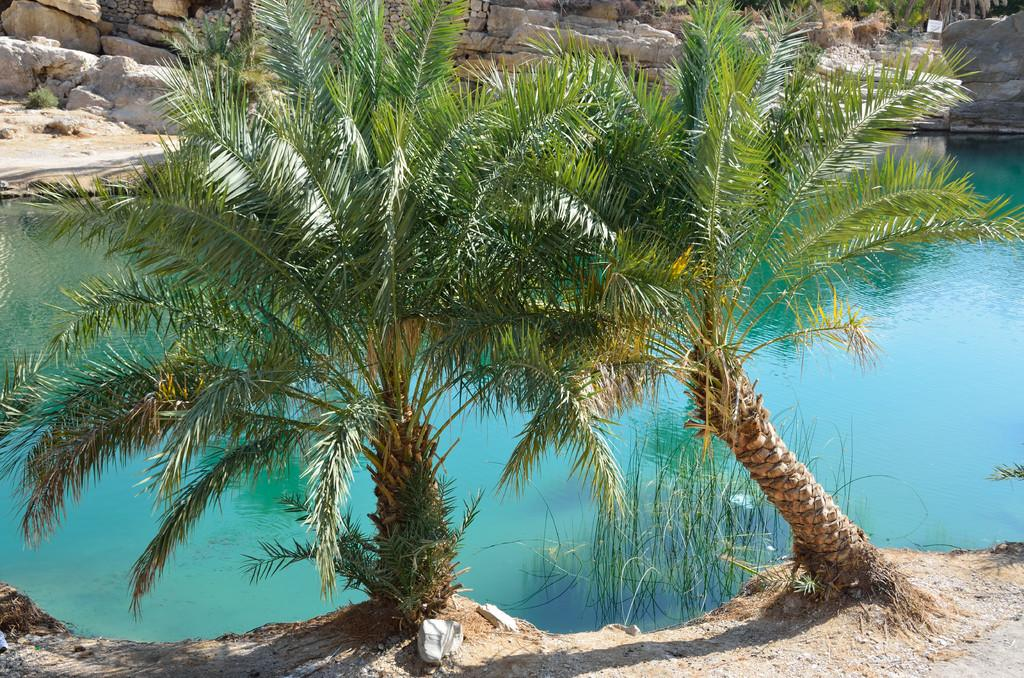What can be seen in the foreground of the image? There are two trees in the foreground of the image. What is visible in the image besides the trees? Water is visible in the image. What can be seen in the background of the image? There are stones in the background of the image. What type of experience does the branch have in the image? There is no branch mentioned in the image, so it's not possible to determine any experience it might have. 